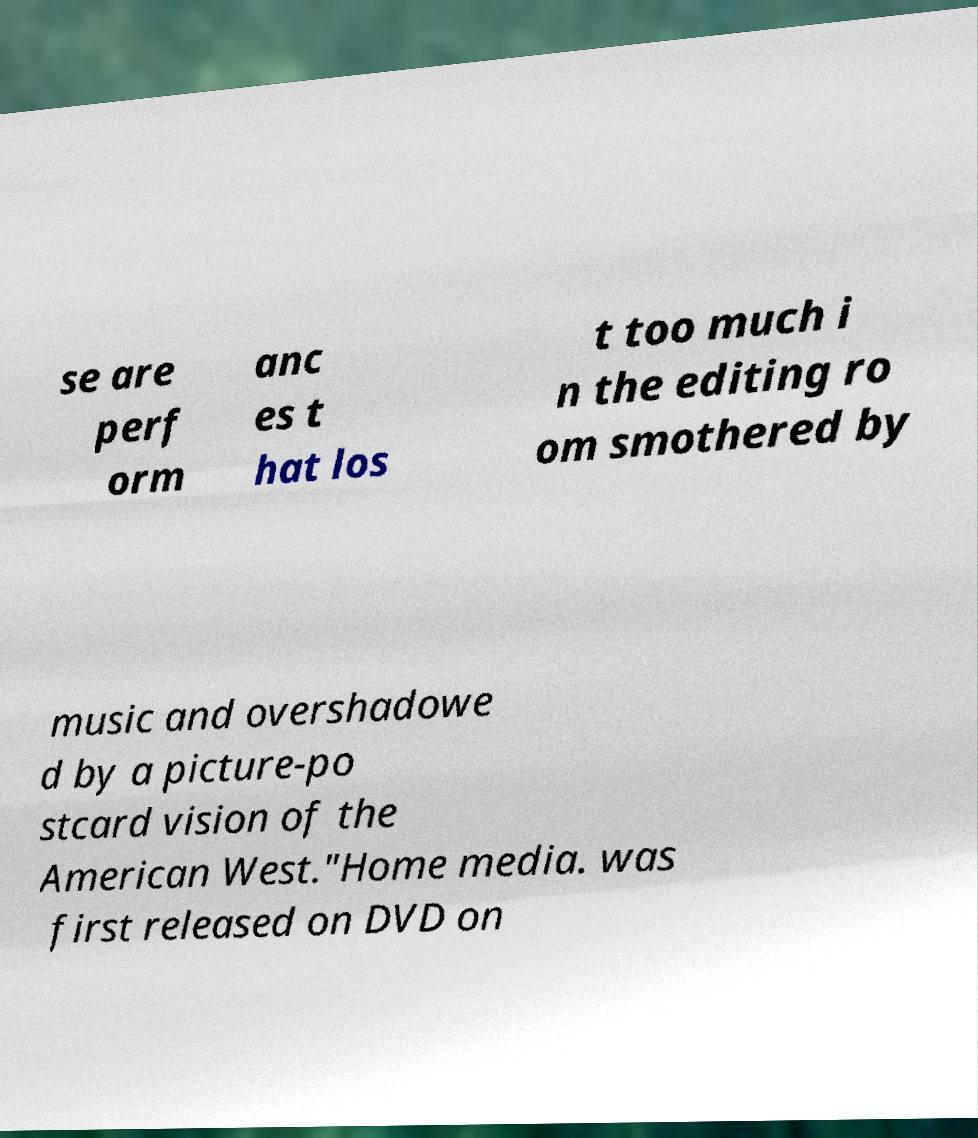Could you assist in decoding the text presented in this image and type it out clearly? se are perf orm anc es t hat los t too much i n the editing ro om smothered by music and overshadowe d by a picture-po stcard vision of the American West."Home media. was first released on DVD on 